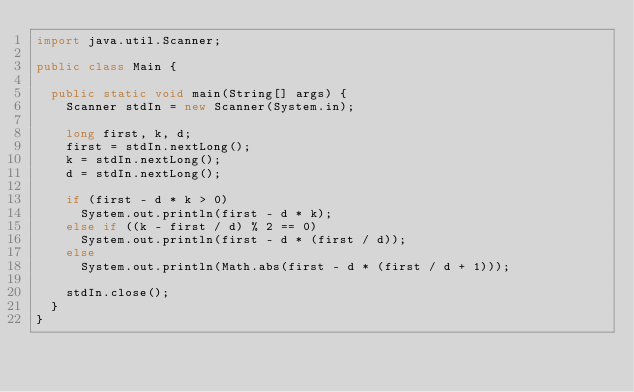<code> <loc_0><loc_0><loc_500><loc_500><_Java_>import java.util.Scanner;

public class Main {

	public static void main(String[] args) {
		Scanner stdIn = new Scanner(System.in);

		long first, k, d;
		first = stdIn.nextLong();
		k = stdIn.nextLong();
		d = stdIn.nextLong();

		if (first - d * k > 0)
			System.out.println(first - d * k);
		else if ((k - first / d) % 2 == 0)
			System.out.println(first - d * (first / d));
		else
			System.out.println(Math.abs(first - d * (first / d + 1)));

		stdIn.close();
	}
}
</code> 